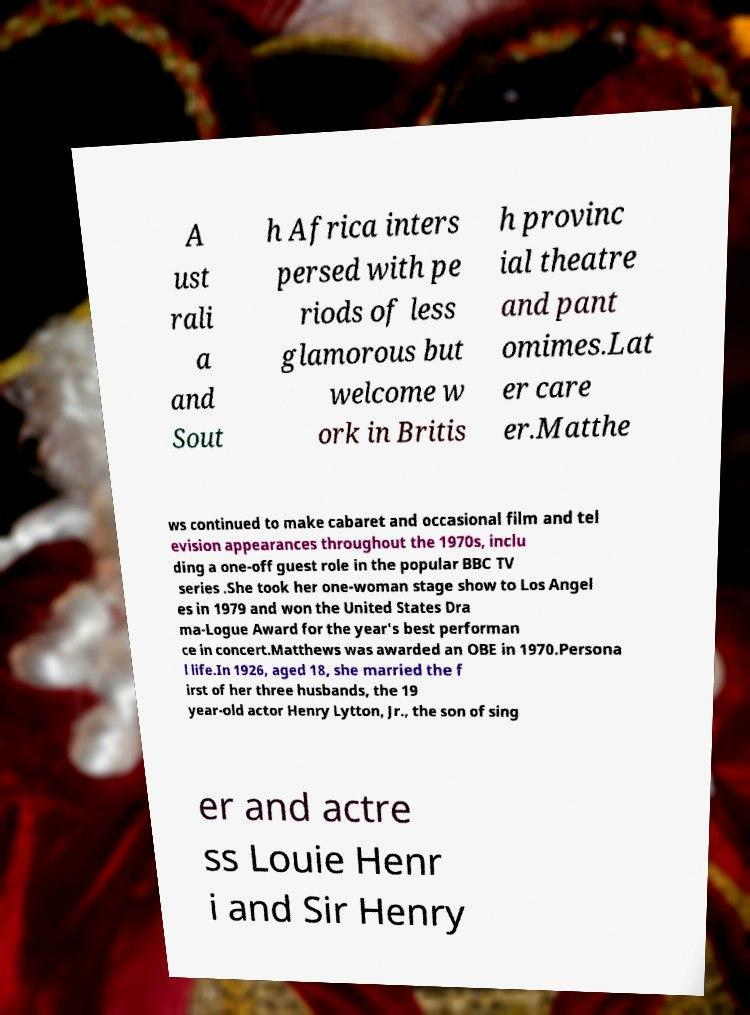For documentation purposes, I need the text within this image transcribed. Could you provide that? A ust rali a and Sout h Africa inters persed with pe riods of less glamorous but welcome w ork in Britis h provinc ial theatre and pant omimes.Lat er care er.Matthe ws continued to make cabaret and occasional film and tel evision appearances throughout the 1970s, inclu ding a one-off guest role in the popular BBC TV series .She took her one-woman stage show to Los Angel es in 1979 and won the United States Dra ma-Logue Award for the year's best performan ce in concert.Matthews was awarded an OBE in 1970.Persona l life.In 1926, aged 18, she married the f irst of her three husbands, the 19 year-old actor Henry Lytton, Jr., the son of sing er and actre ss Louie Henr i and Sir Henry 